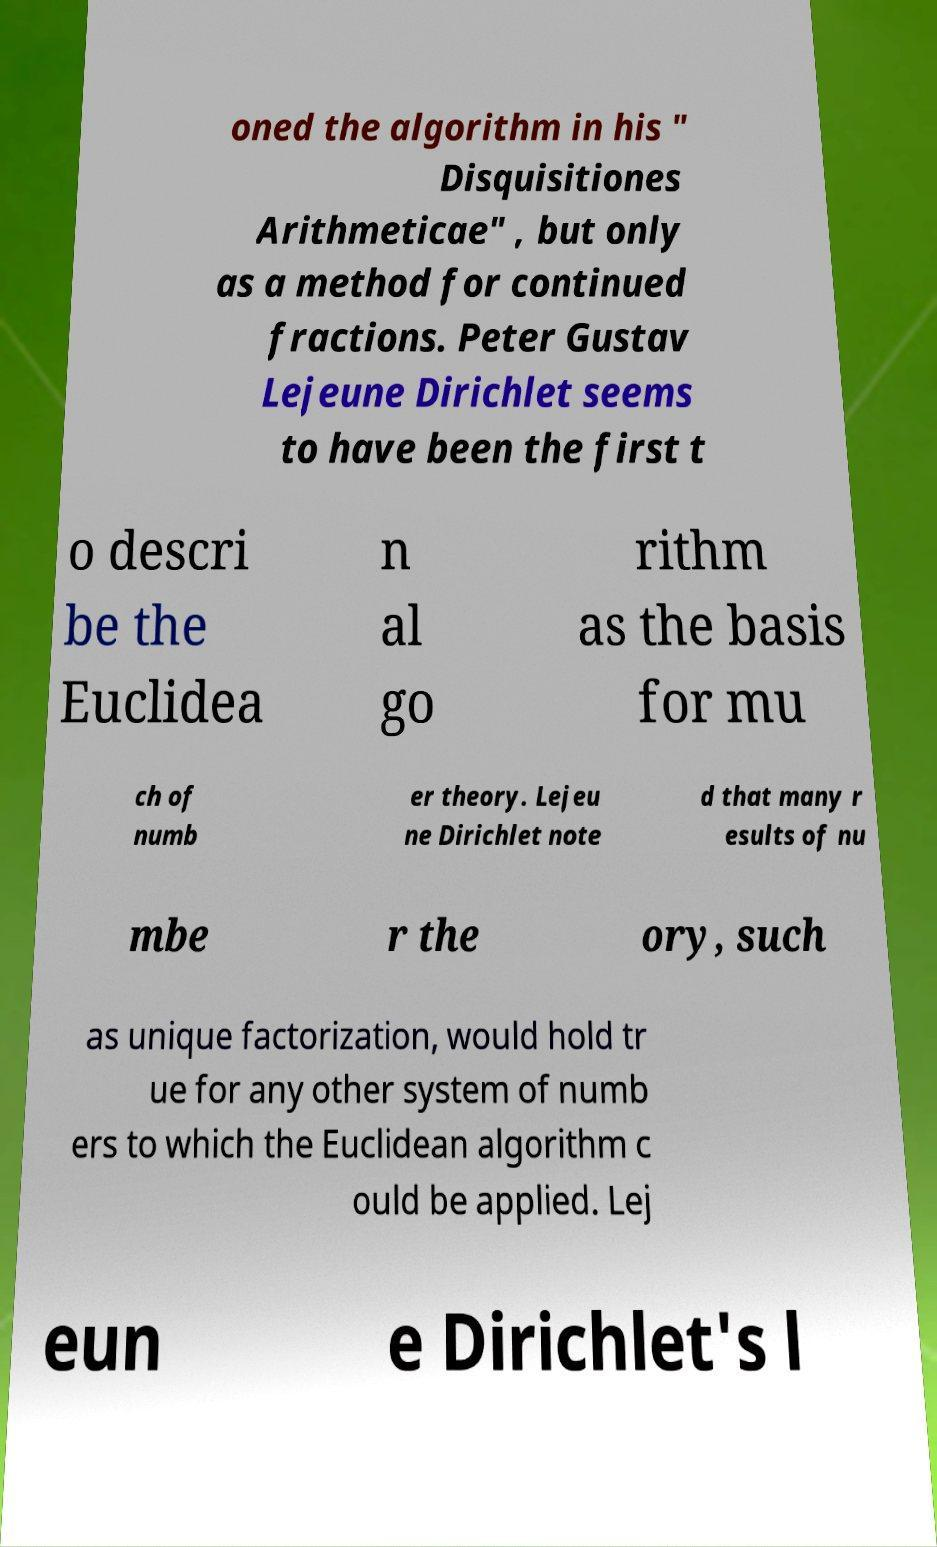Could you assist in decoding the text presented in this image and type it out clearly? oned the algorithm in his " Disquisitiones Arithmeticae" , but only as a method for continued fractions. Peter Gustav Lejeune Dirichlet seems to have been the first t o descri be the Euclidea n al go rithm as the basis for mu ch of numb er theory. Lejeu ne Dirichlet note d that many r esults of nu mbe r the ory, such as unique factorization, would hold tr ue for any other system of numb ers to which the Euclidean algorithm c ould be applied. Lej eun e Dirichlet's l 